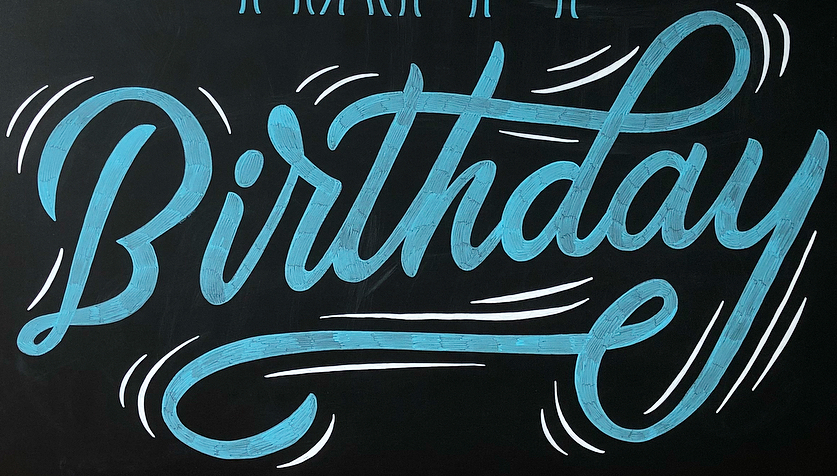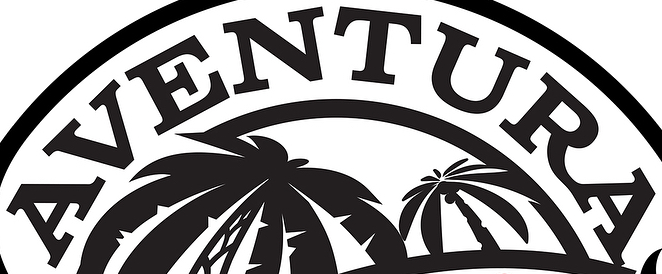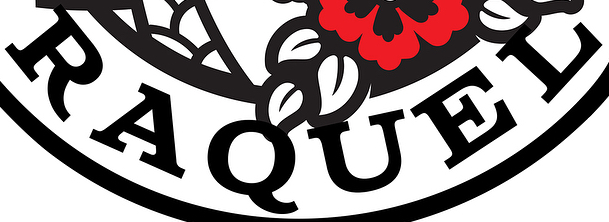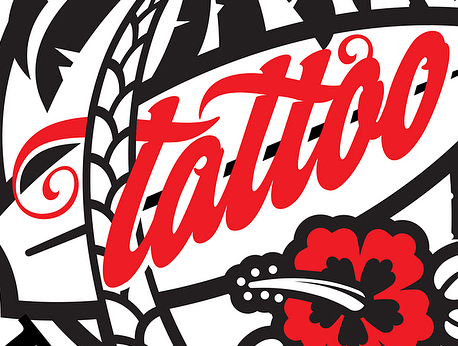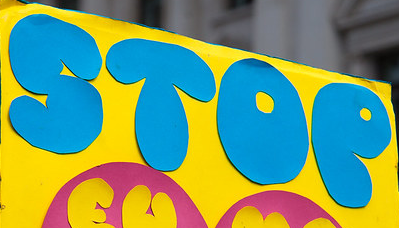Read the text from these images in sequence, separated by a semicolon. Birthday; AVENTURA; RAQUEL; tattao; STOP 